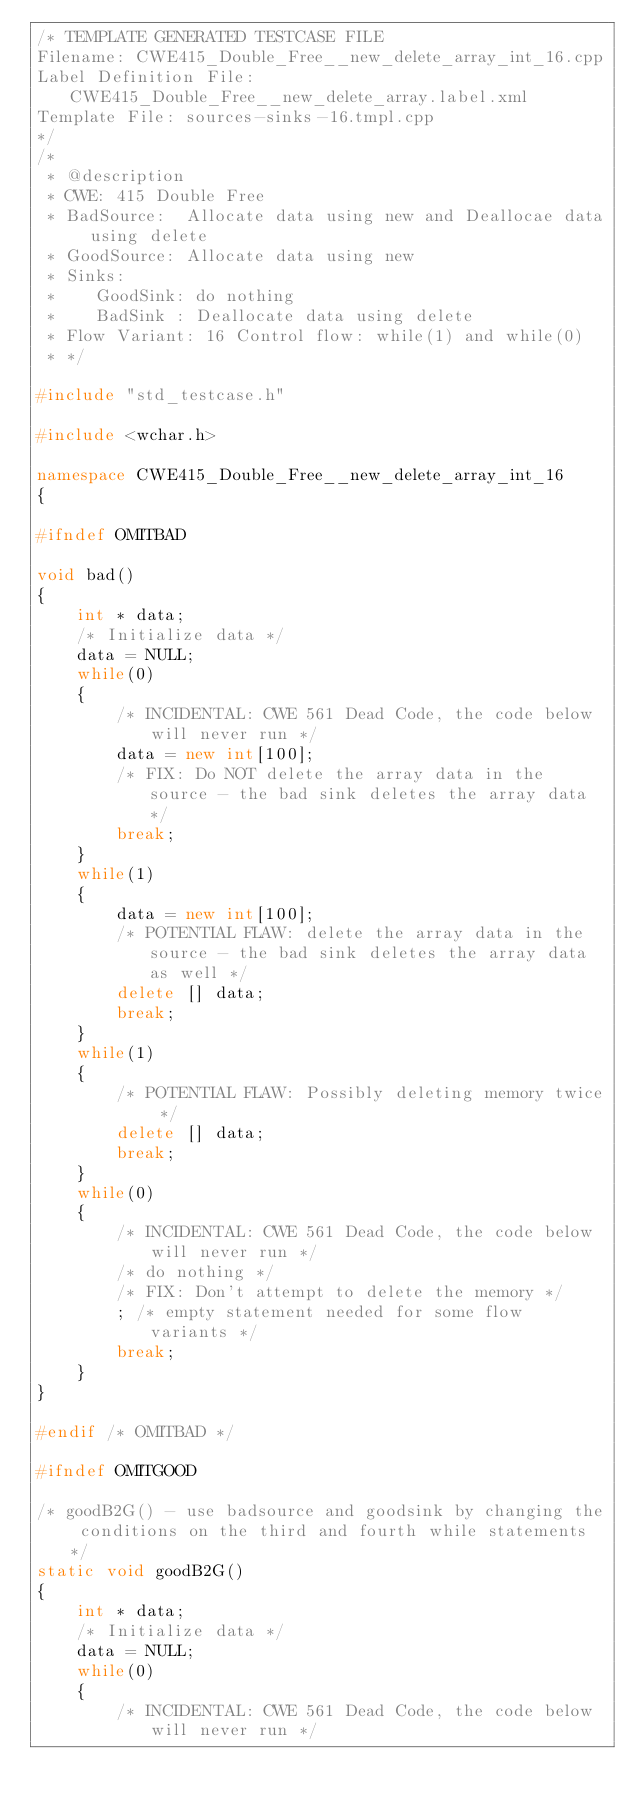<code> <loc_0><loc_0><loc_500><loc_500><_C++_>/* TEMPLATE GENERATED TESTCASE FILE
Filename: CWE415_Double_Free__new_delete_array_int_16.cpp
Label Definition File: CWE415_Double_Free__new_delete_array.label.xml
Template File: sources-sinks-16.tmpl.cpp
*/
/*
 * @description
 * CWE: 415 Double Free
 * BadSource:  Allocate data using new and Deallocae data using delete
 * GoodSource: Allocate data using new
 * Sinks:
 *    GoodSink: do nothing
 *    BadSink : Deallocate data using delete
 * Flow Variant: 16 Control flow: while(1) and while(0)
 * */

#include "std_testcase.h"

#include <wchar.h>

namespace CWE415_Double_Free__new_delete_array_int_16
{

#ifndef OMITBAD

void bad()
{
    int * data;
    /* Initialize data */
    data = NULL;
    while(0)
    {
        /* INCIDENTAL: CWE 561 Dead Code, the code below will never run */
        data = new int[100];
        /* FIX: Do NOT delete the array data in the source - the bad sink deletes the array data */
        break;
    }
    while(1)
    {
        data = new int[100];
        /* POTENTIAL FLAW: delete the array data in the source - the bad sink deletes the array data as well */
        delete [] data;
        break;
    }
    while(1)
    {
        /* POTENTIAL FLAW: Possibly deleting memory twice */
        delete [] data;
        break;
    }
    while(0)
    {
        /* INCIDENTAL: CWE 561 Dead Code, the code below will never run */
        /* do nothing */
        /* FIX: Don't attempt to delete the memory */
        ; /* empty statement needed for some flow variants */
        break;
    }
}

#endif /* OMITBAD */

#ifndef OMITGOOD

/* goodB2G() - use badsource and goodsink by changing the conditions on the third and fourth while statements */
static void goodB2G()
{
    int * data;
    /* Initialize data */
    data = NULL;
    while(0)
    {
        /* INCIDENTAL: CWE 561 Dead Code, the code below will never run */</code> 